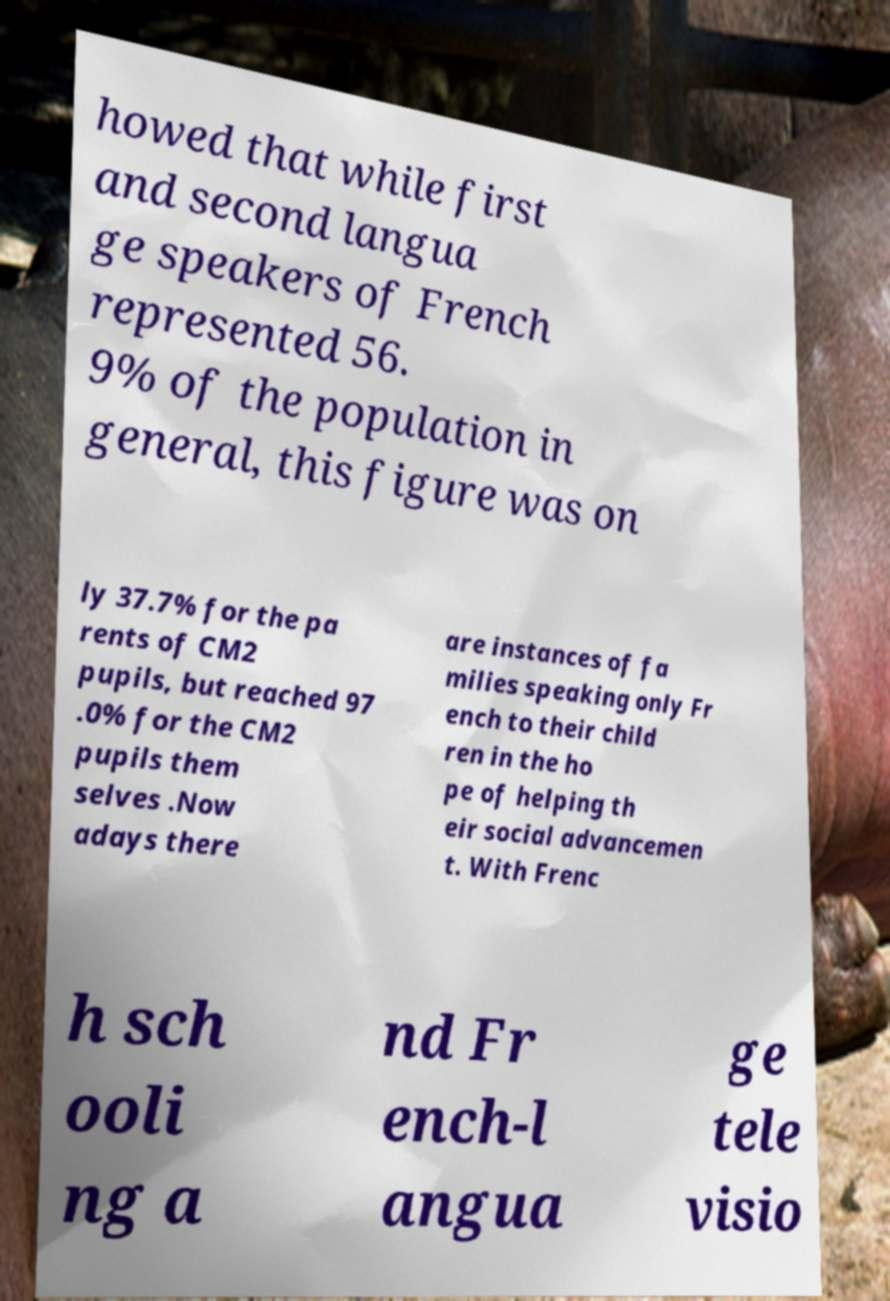Could you extract and type out the text from this image? howed that while first and second langua ge speakers of French represented 56. 9% of the population in general, this figure was on ly 37.7% for the pa rents of CM2 pupils, but reached 97 .0% for the CM2 pupils them selves .Now adays there are instances of fa milies speaking only Fr ench to their child ren in the ho pe of helping th eir social advancemen t. With Frenc h sch ooli ng a nd Fr ench-l angua ge tele visio 